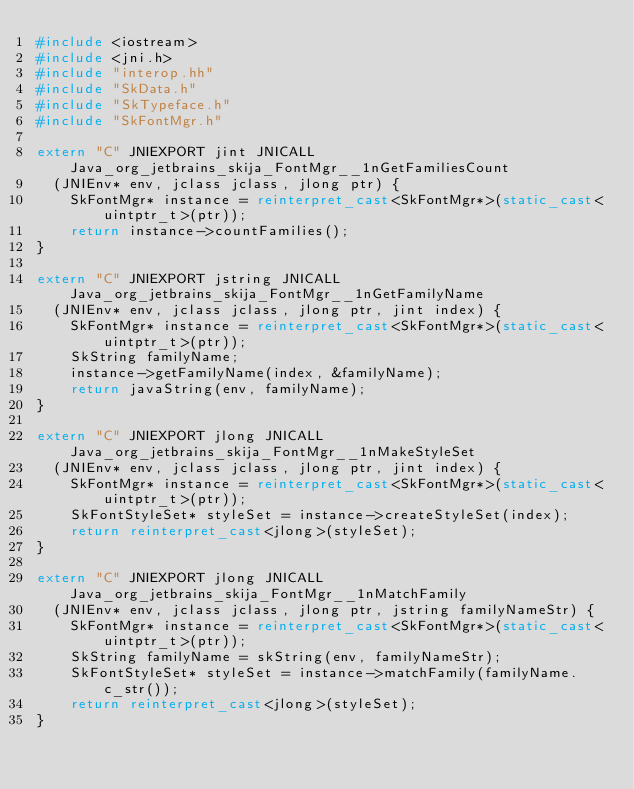Convert code to text. <code><loc_0><loc_0><loc_500><loc_500><_C++_>#include <iostream>
#include <jni.h>
#include "interop.hh"
#include "SkData.h"
#include "SkTypeface.h"
#include "SkFontMgr.h"

extern "C" JNIEXPORT jint JNICALL Java_org_jetbrains_skija_FontMgr__1nGetFamiliesCount
  (JNIEnv* env, jclass jclass, jlong ptr) {
    SkFontMgr* instance = reinterpret_cast<SkFontMgr*>(static_cast<uintptr_t>(ptr));
    return instance->countFamilies();
}

extern "C" JNIEXPORT jstring JNICALL Java_org_jetbrains_skija_FontMgr__1nGetFamilyName
  (JNIEnv* env, jclass jclass, jlong ptr, jint index) {
    SkFontMgr* instance = reinterpret_cast<SkFontMgr*>(static_cast<uintptr_t>(ptr));
    SkString familyName;
    instance->getFamilyName(index, &familyName);
    return javaString(env, familyName);
}

extern "C" JNIEXPORT jlong JNICALL Java_org_jetbrains_skija_FontMgr__1nMakeStyleSet
  (JNIEnv* env, jclass jclass, jlong ptr, jint index) {
    SkFontMgr* instance = reinterpret_cast<SkFontMgr*>(static_cast<uintptr_t>(ptr));
    SkFontStyleSet* styleSet = instance->createStyleSet(index);
    return reinterpret_cast<jlong>(styleSet);
}

extern "C" JNIEXPORT jlong JNICALL Java_org_jetbrains_skija_FontMgr__1nMatchFamily
  (JNIEnv* env, jclass jclass, jlong ptr, jstring familyNameStr) {
    SkFontMgr* instance = reinterpret_cast<SkFontMgr*>(static_cast<uintptr_t>(ptr));
    SkString familyName = skString(env, familyNameStr);
    SkFontStyleSet* styleSet = instance->matchFamily(familyName.c_str());
    return reinterpret_cast<jlong>(styleSet);
}
</code> 